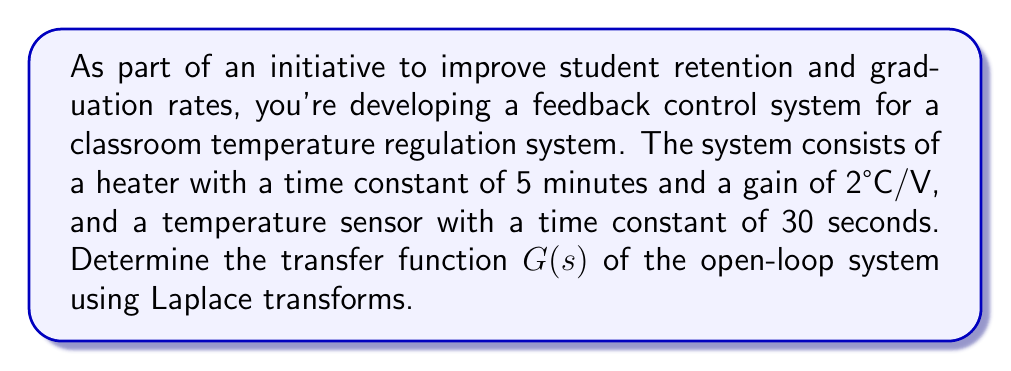Can you answer this question? Let's approach this step-by-step:

1) First, we need to identify the transfer functions of each component:

   Heater: The transfer function of a first-order system is given by:
   $$G_h(s) = \frac{K}{1 + \tau s}$$
   where $K$ is the gain and $\tau$ is the time constant.
   For the heater: $K = 2$, $\tau = 5$ minutes = 300 seconds
   $$G_h(s) = \frac{2}{1 + 300s}$$

   Sensor: Similarly, for the sensor:
   $K = 1$ (assuming unity gain for the sensor), $\tau = 30$ seconds
   $$G_s(s) = \frac{1}{1 + 30s}$$

2) The open-loop transfer function is the product of these two transfer functions:

   $$G(s) = G_h(s) \cdot G_s(s)$$

3) Multiplying the transfer functions:

   $$G(s) = \frac{2}{1 + 300s} \cdot \frac{1}{1 + 30s}$$

4) Simplifying:

   $$G(s) = \frac{2}{(1 + 300s)(1 + 30s)}$$
   
   $$G(s) = \frac{2}{1 + 330s + 9000s^2}$$

This final form is the open-loop transfer function of the system.
Answer: $$G(s) = \frac{2}{1 + 330s + 9000s^2}$$ 